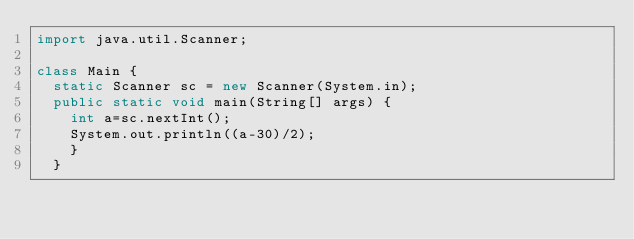Convert code to text. <code><loc_0><loc_0><loc_500><loc_500><_Java_>import java.util.Scanner;

class Main {
	static Scanner sc = new Scanner(System.in);
	public static void main(String[] args) {
		int a=sc.nextInt();
		System.out.println((a-30)/2);
		}
	}


</code> 